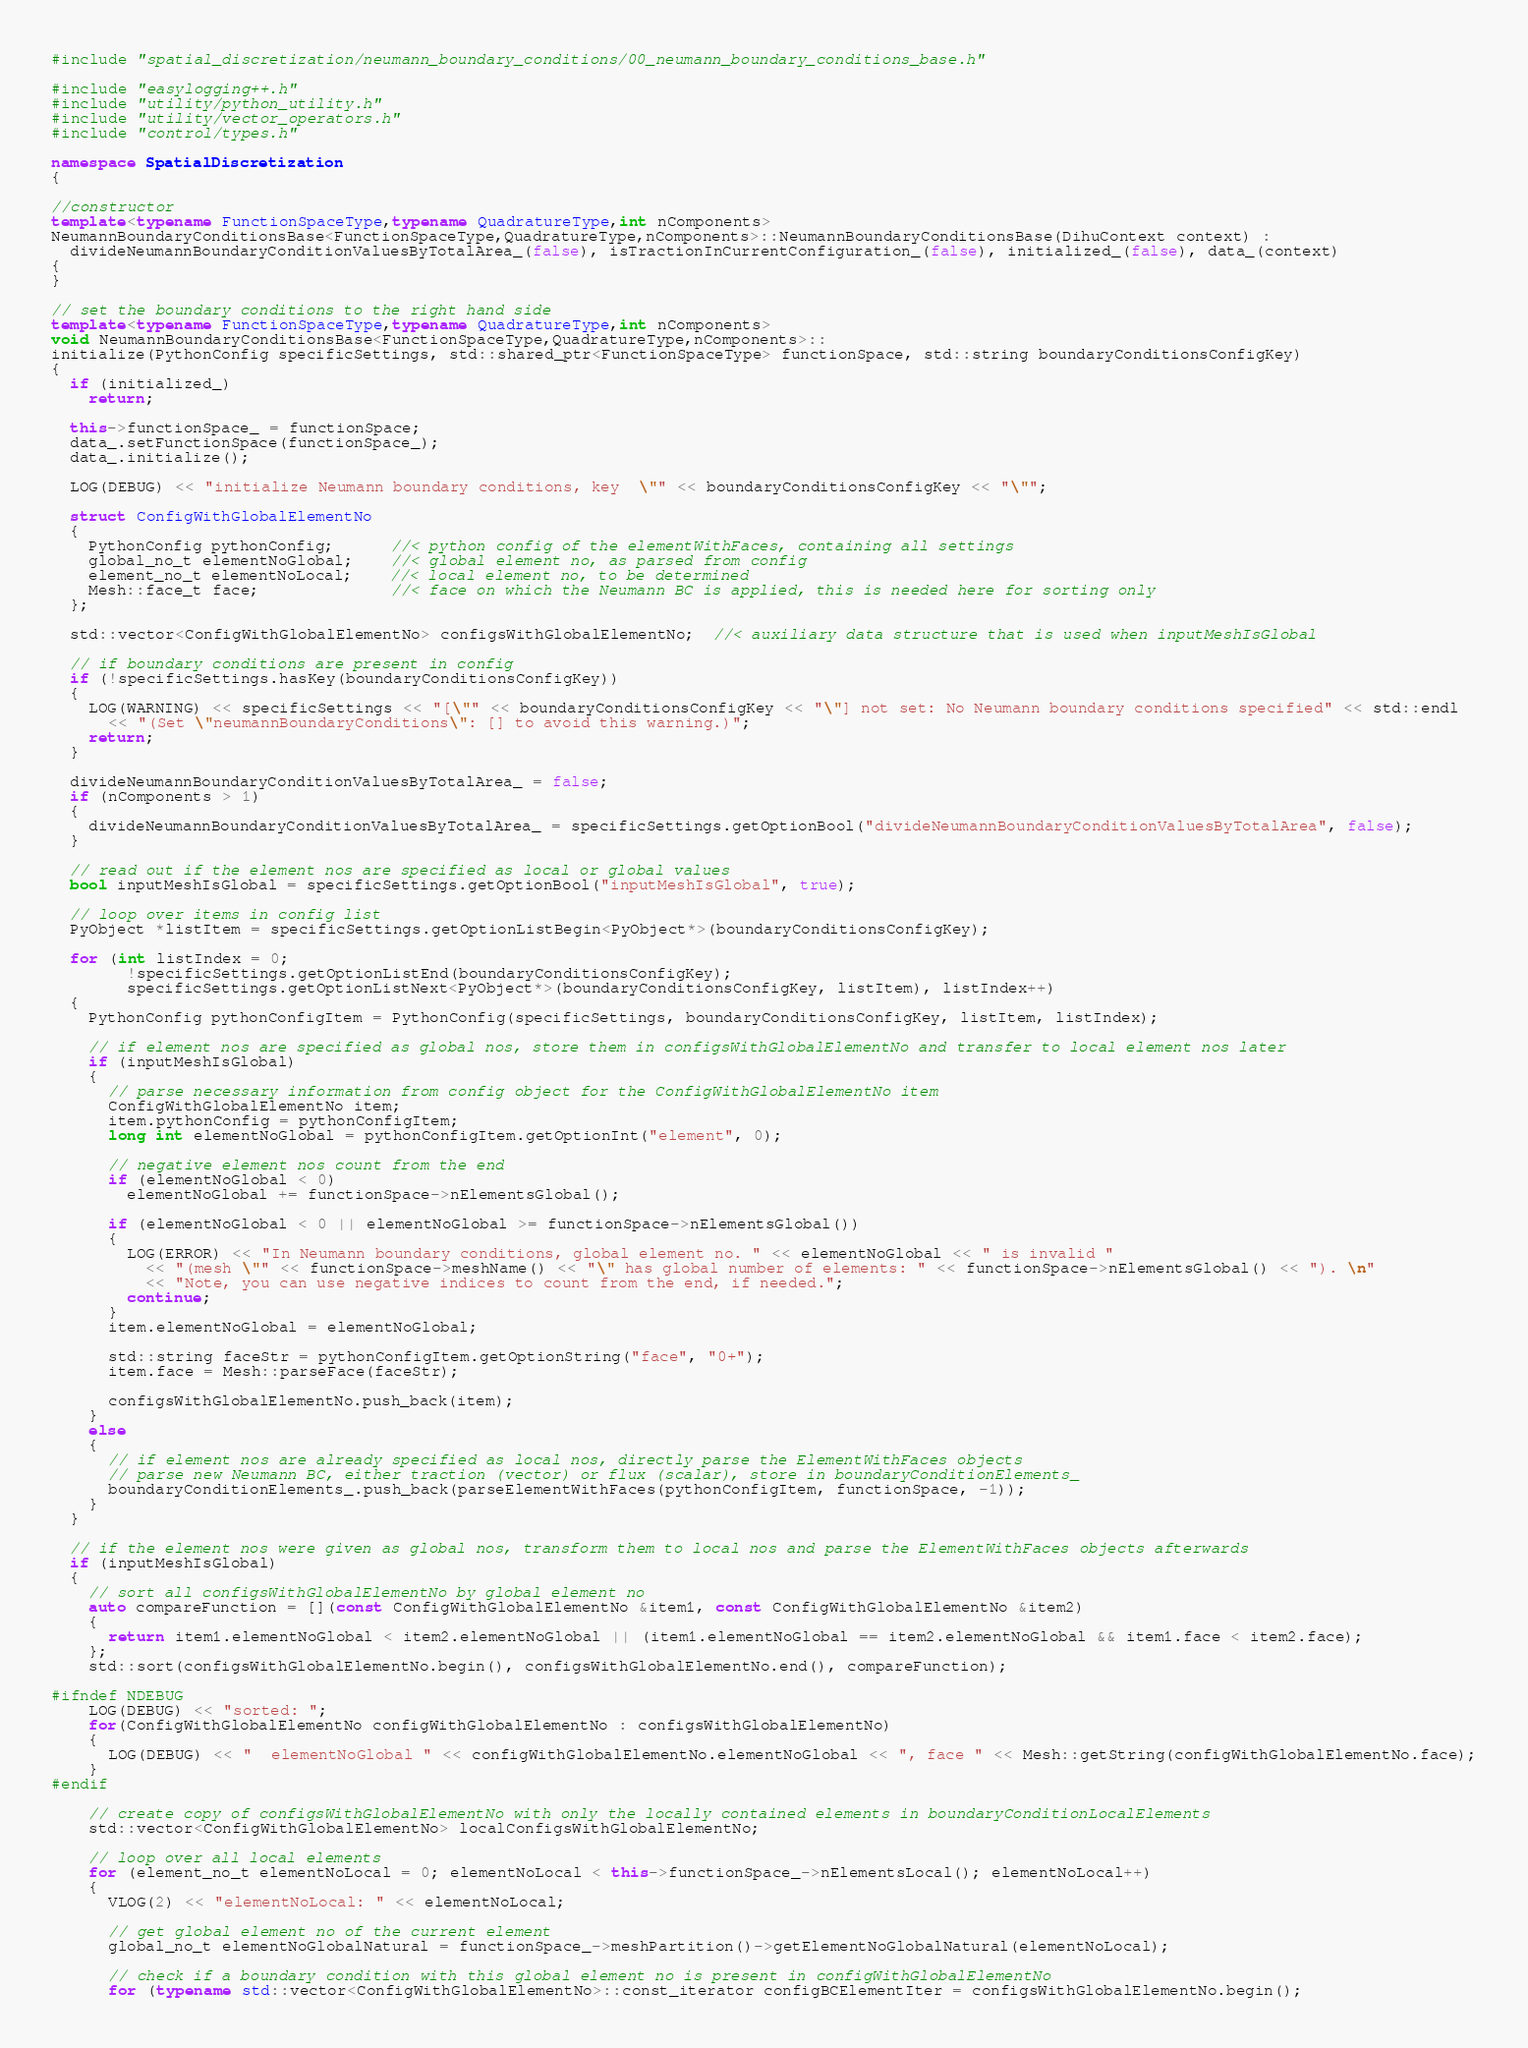Convert code to text. <code><loc_0><loc_0><loc_500><loc_500><_C++_>#include "spatial_discretization/neumann_boundary_conditions/00_neumann_boundary_conditions_base.h"

#include "easylogging++.h"
#include "utility/python_utility.h"
#include "utility/vector_operators.h"
#include "control/types.h"

namespace SpatialDiscretization
{

//constructor
template<typename FunctionSpaceType,typename QuadratureType,int nComponents>
NeumannBoundaryConditionsBase<FunctionSpaceType,QuadratureType,nComponents>::NeumannBoundaryConditionsBase(DihuContext context) :
  divideNeumannBoundaryConditionValuesByTotalArea_(false), isTractionInCurrentConfiguration_(false), initialized_(false), data_(context)
{
}

// set the boundary conditions to the right hand side
template<typename FunctionSpaceType,typename QuadratureType,int nComponents>
void NeumannBoundaryConditionsBase<FunctionSpaceType,QuadratureType,nComponents>::
initialize(PythonConfig specificSettings, std::shared_ptr<FunctionSpaceType> functionSpace, std::string boundaryConditionsConfigKey)
{
  if (initialized_)
    return;

  this->functionSpace_ = functionSpace;
  data_.setFunctionSpace(functionSpace_);
  data_.initialize();

  LOG(DEBUG) << "initialize Neumann boundary conditions, key  \"" << boundaryConditionsConfigKey << "\"";

  struct ConfigWithGlobalElementNo
  {
    PythonConfig pythonConfig;      //< python config of the elementWithFaces, containing all settings
    global_no_t elementNoGlobal;    //< global element no, as parsed from config
    element_no_t elementNoLocal;    //< local element no, to be determined
    Mesh::face_t face;              //< face on which the Neumann BC is applied, this is needed here for sorting only
  };

  std::vector<ConfigWithGlobalElementNo> configsWithGlobalElementNo;  //< auxiliary data structure that is used when inputMeshIsGlobal

  // if boundary conditions are present in config
  if (!specificSettings.hasKey(boundaryConditionsConfigKey))
  {
    LOG(WARNING) << specificSettings << "[\"" << boundaryConditionsConfigKey << "\"] not set: No Neumann boundary conditions specified" << std::endl
      << "(Set \"neumannBoundaryConditions\": [] to avoid this warning.)";
    return;
  }

  divideNeumannBoundaryConditionValuesByTotalArea_ = false;
  if (nComponents > 1)
  {
    divideNeumannBoundaryConditionValuesByTotalArea_ = specificSettings.getOptionBool("divideNeumannBoundaryConditionValuesByTotalArea", false);
  }

  // read out if the element nos are specified as local or global values
  bool inputMeshIsGlobal = specificSettings.getOptionBool("inputMeshIsGlobal", true);

  // loop over items in config list
  PyObject *listItem = specificSettings.getOptionListBegin<PyObject*>(boundaryConditionsConfigKey);

  for (int listIndex = 0;
        !specificSettings.getOptionListEnd(boundaryConditionsConfigKey);
        specificSettings.getOptionListNext<PyObject*>(boundaryConditionsConfigKey, listItem), listIndex++)
  {
    PythonConfig pythonConfigItem = PythonConfig(specificSettings, boundaryConditionsConfigKey, listItem, listIndex);

    // if element nos are specified as global nos, store them in configsWithGlobalElementNo and transfer to local element nos later
    if (inputMeshIsGlobal)
    {
      // parse necessary information from config object for the ConfigWithGlobalElementNo item
      ConfigWithGlobalElementNo item;
      item.pythonConfig = pythonConfigItem;
      long int elementNoGlobal = pythonConfigItem.getOptionInt("element", 0);

      // negative element nos count from the end
      if (elementNoGlobal < 0)
        elementNoGlobal += functionSpace->nElementsGlobal();

      if (elementNoGlobal < 0 || elementNoGlobal >= functionSpace->nElementsGlobal())
      {
        LOG(ERROR) << "In Neumann boundary conditions, global element no. " << elementNoGlobal << " is invalid "
          << "(mesh \"" << functionSpace->meshName() << "\" has global number of elements: " << functionSpace->nElementsGlobal() << "). \n" 
          << "Note, you can use negative indices to count from the end, if needed.";
        continue;
      }
      item.elementNoGlobal = elementNoGlobal;

      std::string faceStr = pythonConfigItem.getOptionString("face", "0+");
      item.face = Mesh::parseFace(faceStr);

      configsWithGlobalElementNo.push_back(item);
    }
    else
    {
      // if element nos are already specified as local nos, directly parse the ElementWithFaces objects
      // parse new Neumann BC, either traction (vector) or flux (scalar), store in boundaryConditionElements_
      boundaryConditionElements_.push_back(parseElementWithFaces(pythonConfigItem, functionSpace, -1));
    }
  }

  // if the element nos were given as global nos, transform them to local nos and parse the ElementWithFaces objects afterwards
  if (inputMeshIsGlobal)
  {
    // sort all configsWithGlobalElementNo by global element no
    auto compareFunction = [](const ConfigWithGlobalElementNo &item1, const ConfigWithGlobalElementNo &item2)
    {
      return item1.elementNoGlobal < item2.elementNoGlobal || (item1.elementNoGlobal == item2.elementNoGlobal && item1.face < item2.face);
    };
    std::sort(configsWithGlobalElementNo.begin(), configsWithGlobalElementNo.end(), compareFunction);

#ifndef NDEBUG
    LOG(DEBUG) << "sorted: ";
    for(ConfigWithGlobalElementNo configWithGlobalElementNo : configsWithGlobalElementNo)
    {
      LOG(DEBUG) << "  elementNoGlobal " << configWithGlobalElementNo.elementNoGlobal << ", face " << Mesh::getString(configWithGlobalElementNo.face);
    }
#endif

    // create copy of configsWithGlobalElementNo with only the locally contained elements in boundaryConditionLocalElements
    std::vector<ConfigWithGlobalElementNo> localConfigsWithGlobalElementNo;

    // loop over all local elements
    for (element_no_t elementNoLocal = 0; elementNoLocal < this->functionSpace_->nElementsLocal(); elementNoLocal++)
    {
      VLOG(2) << "elementNoLocal: " << elementNoLocal;

      // get global element no of the current element
      global_no_t elementNoGlobalNatural = functionSpace_->meshPartition()->getElementNoGlobalNatural(elementNoLocal);

      // check if a boundary condition with this global element no is present in configWithGlobalElementNo
      for (typename std::vector<ConfigWithGlobalElementNo>::const_iterator configBCElementIter = configsWithGlobalElementNo.begin();</code> 